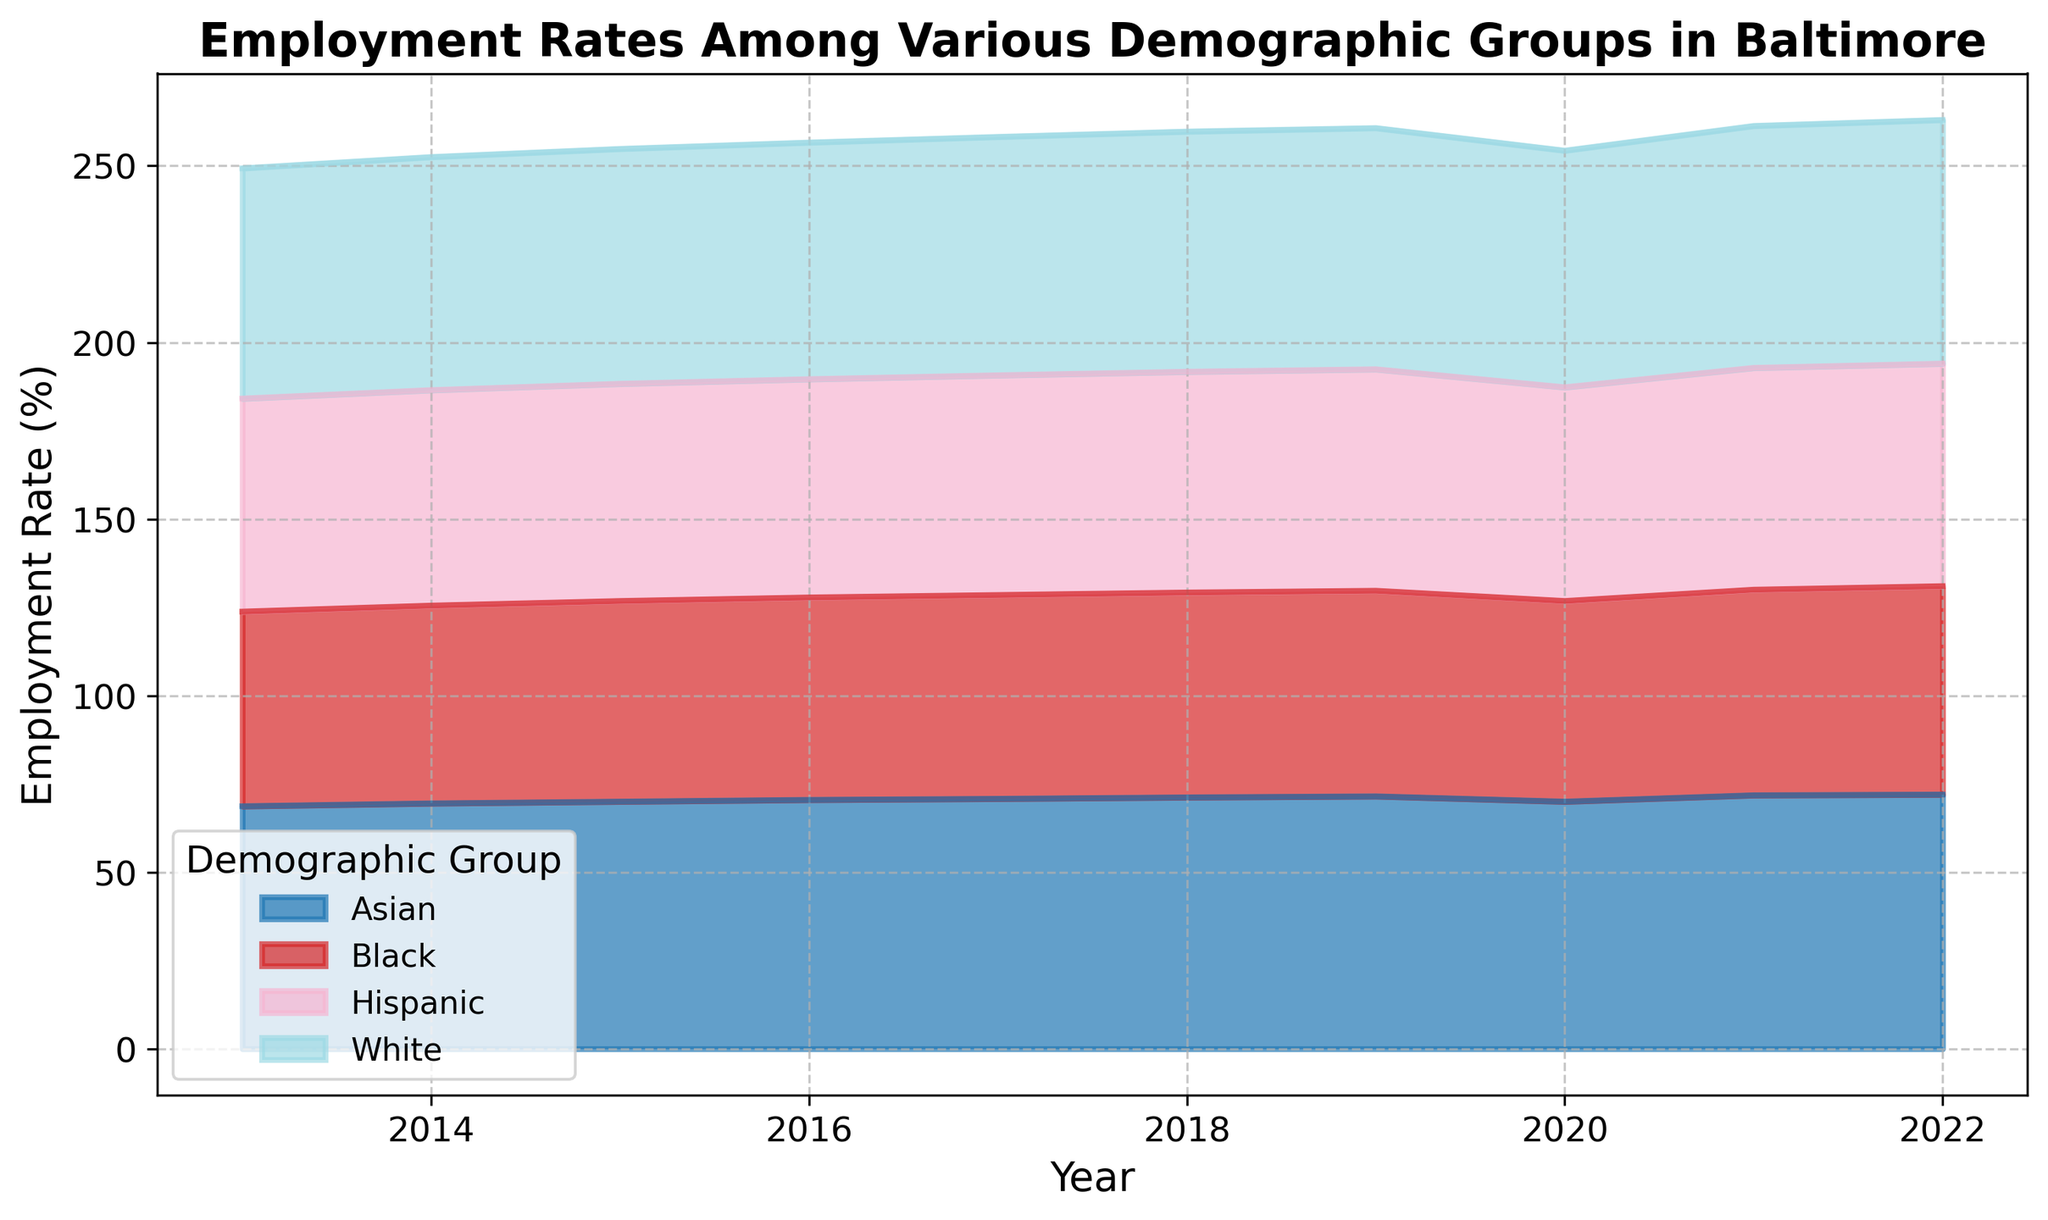What was the employment rate trend for each demographic group from 2013 to 2022? Look at the area representing each demographic group over the years. Observe whether the employment rate is rising, falling, or remaining constant for each group from 2013 to 2022. For White, Black, Hispanic, and Asian, the employment rates generally increase over the years.
Answer: Increasing Which demographic group had the highest employment rate in 2022? Identify the group with the tallest area section in 2022. The Asian demographic group has the highest employment rate.
Answer: Asian How did the employment rates for Black and Hispanic groups compare in 2020? Look at the heights of the area sections for Black and Hispanic in the year 2020. The Black group's employment rate was 56.8%, and the Hispanic group's was 60.5%.
Answer: Hispanic > Black What is the difference in the employment rate between the White and Black demographic groups in 2013? Find the employment rates for White and Black groups in 2013 and subtract the latter from the former. White rate is 65.2%, and Black rate is 55.1%. The difference is 65.2 - 55.1 = 10.1%.
Answer: 10.1% Which demographic group showed the smallest change in employment rate from 2013 to 2022? Calculate the change in employment rates for each group from 2013 to 2022 and determine the smallest change. White (69.0 - 65.2), Black (59.0 - 55.1), Hispanic (63.0 - 60.3), Asian (72.0 - 68.7). The smallest change is for the Hispanic group: 63.0 - 60.3 = 2.7.
Answer: Hispanic Among the Hispanic group, which year showed the highest employment rate? Identify the tallest section of the Hispanic group's area across all the years. The year 2022 has the highest employment rate for Hispanics at 63.0%.
Answer: 2022 In which year did the Asian demographic first reach an employment rate of 70% or above? From the area representing the Asian group, identify the first year where the height reaches or exceeds 70%. This first occurs in 2015 when the employment rate is 70%.
Answer: 2015 Compare the employment rate trends between the White and Asian groups from 2015 to 2020. Examine and compare the area heights for White and Asian groups from 2015 through 2020. Both trends increase initially and then decline slightly in 2020.
Answer: Similar What was the average employment rate for the Black demographic group over the decade? Add the employment rates for the Black group for each year and divide by the number of years (10). The sum is 55.1 + 56.0 + 56.8 + 57.3 + 57.7 + 58.0 + 58.2 + 56.8 + 58.2 + 59.0 = 573.1, so the average is 573.1 / 10 = 57.31%.
Answer: 57.31% Has the employment rate gap between the White and Black groups widened or narrowed from 2013 to 2022? Calculate the employment rate gap for the White and Black groups in 2013 and 2022 and compare the differences. In 2013, the gap is 65.2 - 55.1 = 10.1%. In 2022, the gap is 69.0 - 59.0 = 10.0%. The gap has slightly narrowed.
Answer: Narrowed 